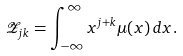<formula> <loc_0><loc_0><loc_500><loc_500>\mathcal { Z } _ { j k } = \int _ { - \infty } ^ { \infty } x ^ { j + k } \mu ( x ) \, d x .</formula> 